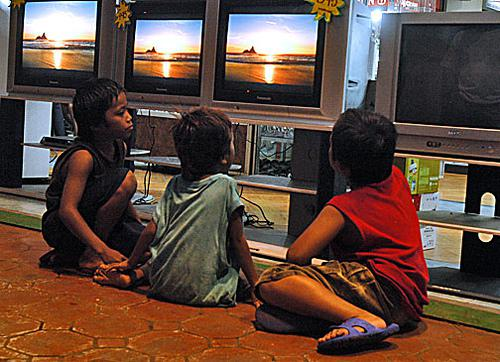Question: how many boys are pictured?
Choices:
A. 2.
B. 3.
C. 4.
D. 5.
Answer with the letter. Answer: B Question: when is this picture taken?
Choices:
A. While the woman is making dinner.
B. While the man is sitting in front of the fireplace.
C. While the dogs are playing on the rug.
D. While the boys are watching TV.
Answer with the letter. Answer: D Question: what time of day is it?
Choices:
A. Night time.
B. Very early morning.
C. Day time.
D. Dusk.
Answer with the letter. Answer: C Question: who is pictured?
Choices:
A. Three dogs.
B. Three women.
C. Three boys.
D. Three elderly men.
Answer with the letter. Answer: C Question: what color is the hair of the boy on the right?
Choices:
A. Blonde.
B. Brown.
C. White.
D. Black.
Answer with the letter. Answer: D Question: where is this picture taken?
Choices:
A. Kitchen.
B. School.
C. Store.
D. Library.
Answer with the letter. Answer: C 